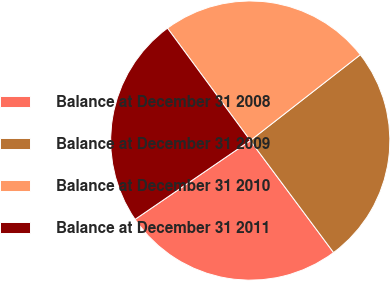Convert chart to OTSL. <chart><loc_0><loc_0><loc_500><loc_500><pie_chart><fcel>Balance at December 31 2008<fcel>Balance at December 31 2009<fcel>Balance at December 31 2010<fcel>Balance at December 31 2011<nl><fcel>25.63%<fcel>25.36%<fcel>24.56%<fcel>24.44%<nl></chart> 